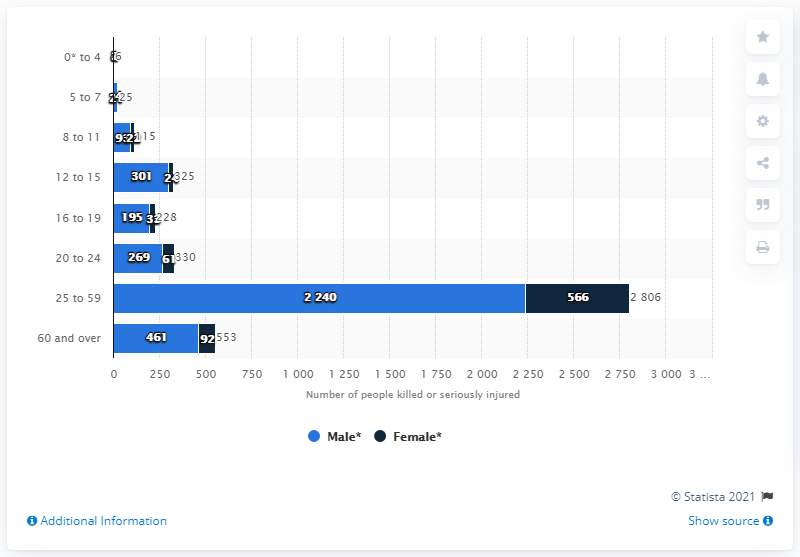Highlight a few significant elements in this photo. In 2019, a total of 269 male cyclists were killed or seriously injured in road accidents in Great Britain. 